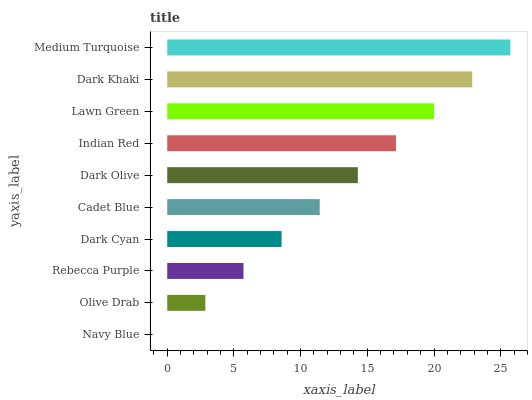Is Navy Blue the minimum?
Answer yes or no. Yes. Is Medium Turquoise the maximum?
Answer yes or no. Yes. Is Olive Drab the minimum?
Answer yes or no. No. Is Olive Drab the maximum?
Answer yes or no. No. Is Olive Drab greater than Navy Blue?
Answer yes or no. Yes. Is Navy Blue less than Olive Drab?
Answer yes or no. Yes. Is Navy Blue greater than Olive Drab?
Answer yes or no. No. Is Olive Drab less than Navy Blue?
Answer yes or no. No. Is Dark Olive the high median?
Answer yes or no. Yes. Is Cadet Blue the low median?
Answer yes or no. Yes. Is Navy Blue the high median?
Answer yes or no. No. Is Rebecca Purple the low median?
Answer yes or no. No. 